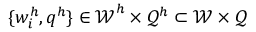<formula> <loc_0><loc_0><loc_500><loc_500>\{ w _ { i } ^ { h } , q ^ { h } \} \in \mathcal { W } ^ { h } \times \mathcal { Q } ^ { h } \subset \mathcal { W } \times \mathcal { Q }</formula> 